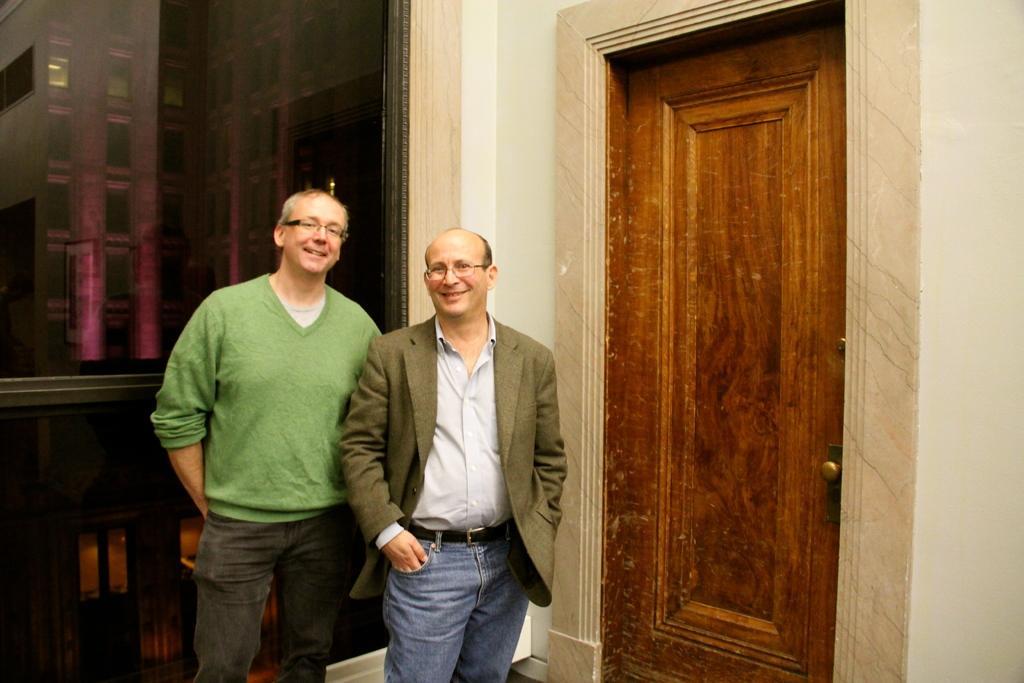Describe this image in one or two sentences. In the center of the image we can see persons standing on the floor. On the right side of the image there is a door. In the background we can see window and building. 